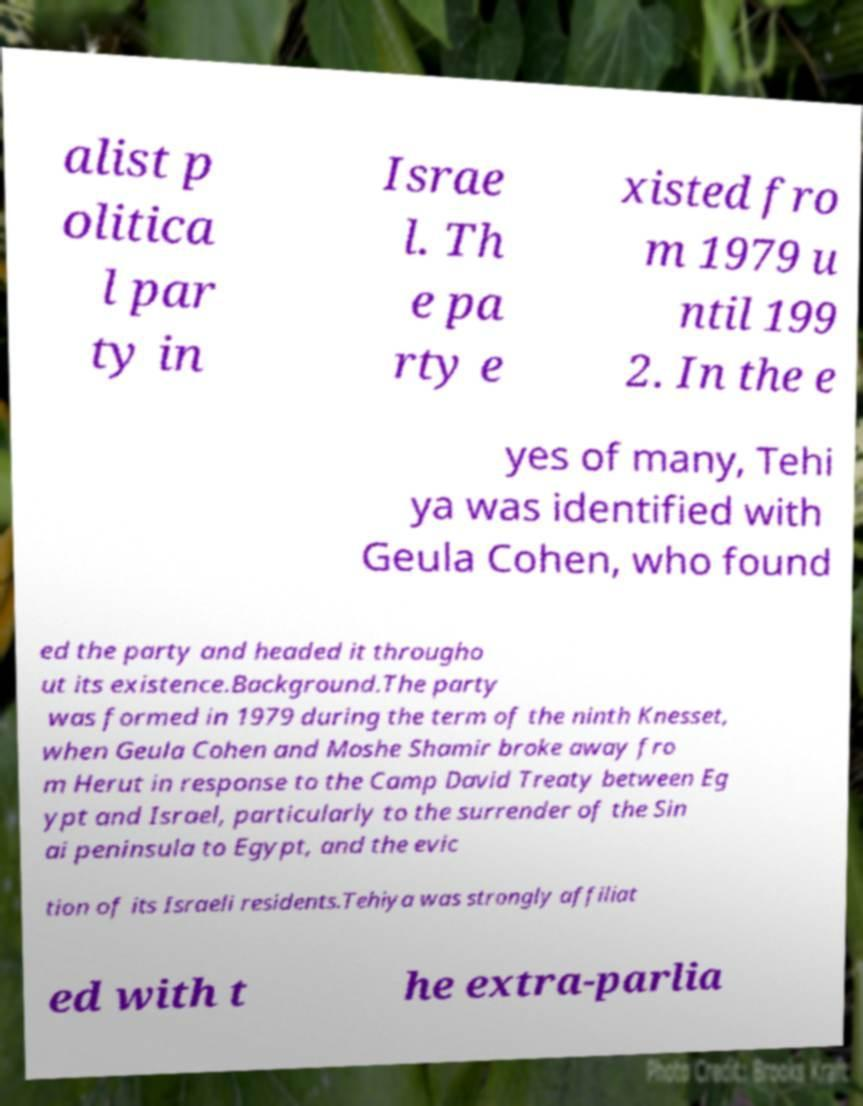Could you extract and type out the text from this image? alist p olitica l par ty in Israe l. Th e pa rty e xisted fro m 1979 u ntil 199 2. In the e yes of many, Tehi ya was identified with Geula Cohen, who found ed the party and headed it througho ut its existence.Background.The party was formed in 1979 during the term of the ninth Knesset, when Geula Cohen and Moshe Shamir broke away fro m Herut in response to the Camp David Treaty between Eg ypt and Israel, particularly to the surrender of the Sin ai peninsula to Egypt, and the evic tion of its Israeli residents.Tehiya was strongly affiliat ed with t he extra-parlia 